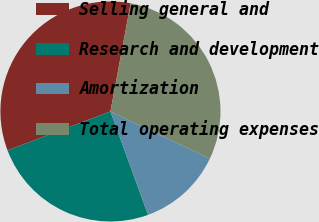<chart> <loc_0><loc_0><loc_500><loc_500><pie_chart><fcel>Selling general and<fcel>Research and development<fcel>Amortization<fcel>Total operating expenses<nl><fcel>33.69%<fcel>24.8%<fcel>12.4%<fcel>29.11%<nl></chart> 